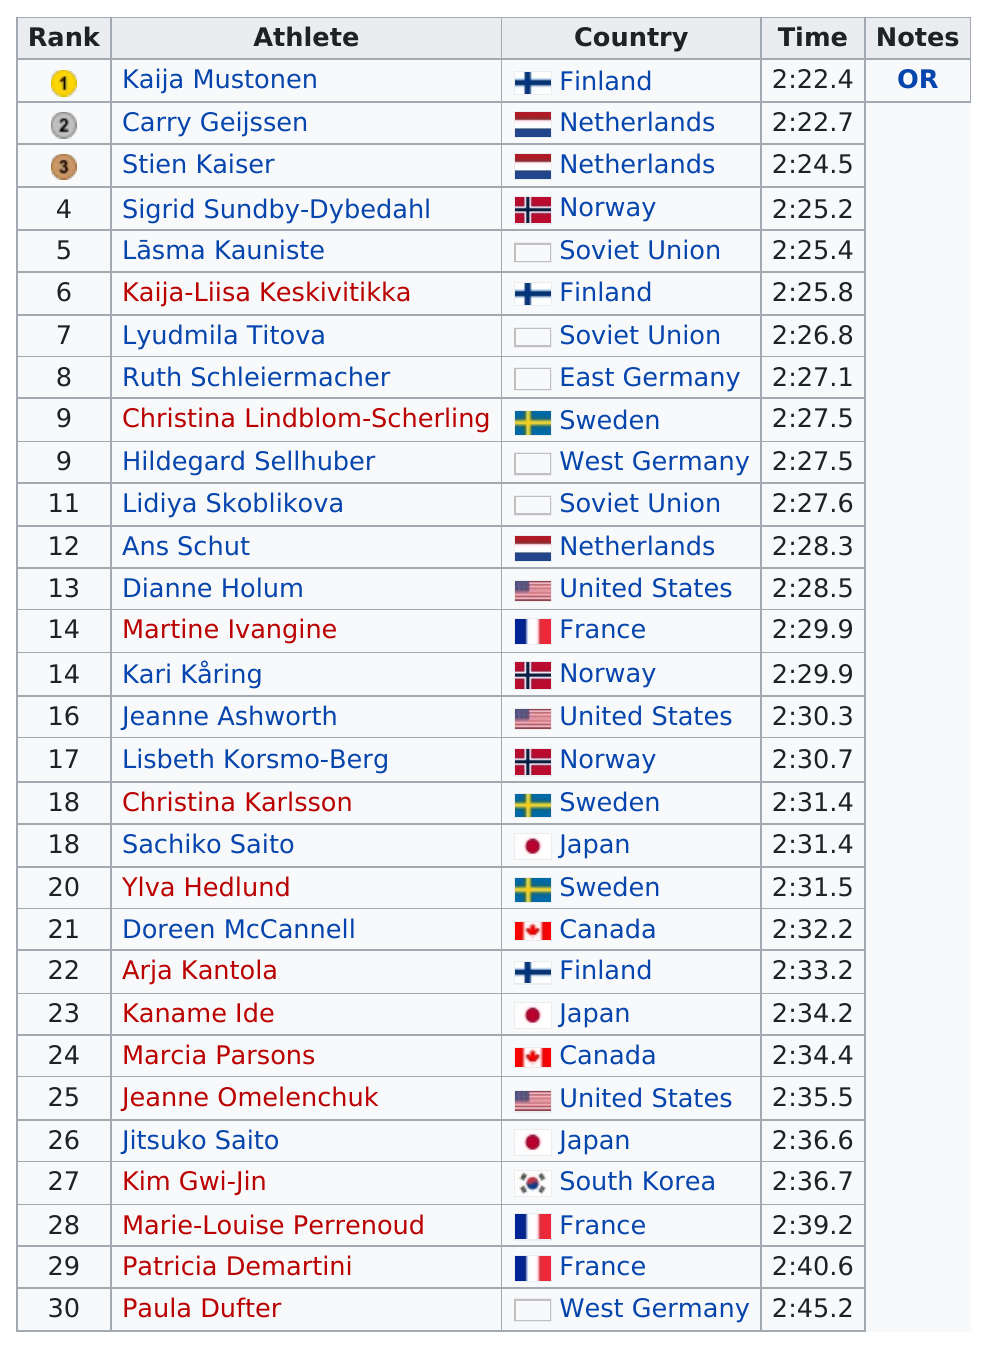Draw attention to some important aspects in this diagram. There are a total of 3 ties listed. Out of the top 30 competitors, only 3 of them are from Norway. The next competitor from Finland, Kaija-Liisa Keskivitikka, placed second after the gold medalist, Kaija Mustonen. Paula Dufter, the last-place competitor in the competition, demonstrates our commitment to continuous improvement and dedication to excellence. Kaija Mustonen was the top speed skiing competitor at the 1968 Winter Olympics, and she is from Finland. 